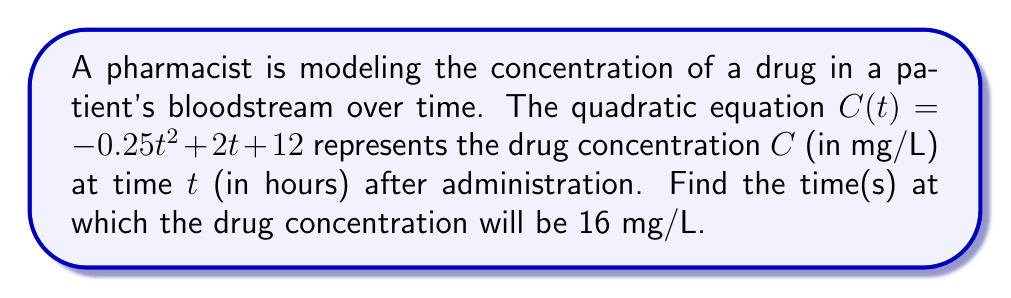Teach me how to tackle this problem. To solve this problem, we need to find the roots of the quadratic equation:

$C(t) = -0.25t^2 + 2t + 12 = 16$

1. Rearrange the equation to standard form $(at^2 + bt + c = 0)$:
   $-0.25t^2 + 2t + (12 - 16) = 0$
   $-0.25t^2 + 2t - 4 = 0$

2. Multiply all terms by -4 to eliminate fractions:
   $t^2 - 8t + 16 = 0$

3. Use the quadratic formula: $t = \frac{-b \pm \sqrt{b^2 - 4ac}}{2a}$
   Where $a = 1$, $b = -8$, and $c = 16$

4. Substitute into the quadratic formula:
   $t = \frac{-(-8) \pm \sqrt{(-8)^2 - 4(1)(16)}}{2(1)}$
   $= \frac{8 \pm \sqrt{64 - 64}}{2}$
   $= \frac{8 \pm 0}{2}$
   $= 4$

5. The equation has only one solution, $t = 4$, which is a double root.

Therefore, the drug concentration will be 16 mg/L at 4 hours after administration.
Answer: $t = 4$ hours 